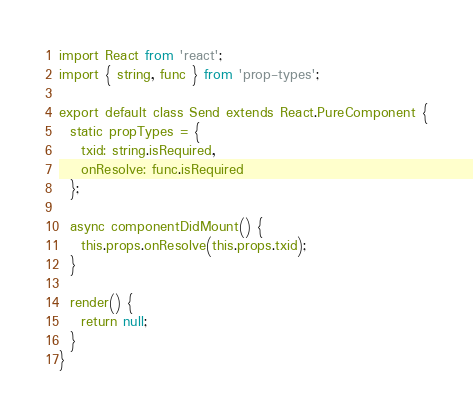<code> <loc_0><loc_0><loc_500><loc_500><_JavaScript_>import React from 'react';
import { string, func } from 'prop-types';

export default class Send extends React.PureComponent {
  static propTypes = {
    txid: string.isRequired,
    onResolve: func.isRequired
  };

  async componentDidMount() {
    this.props.onResolve(this.props.txid);
  }

  render() {
    return null;
  }
}
</code> 